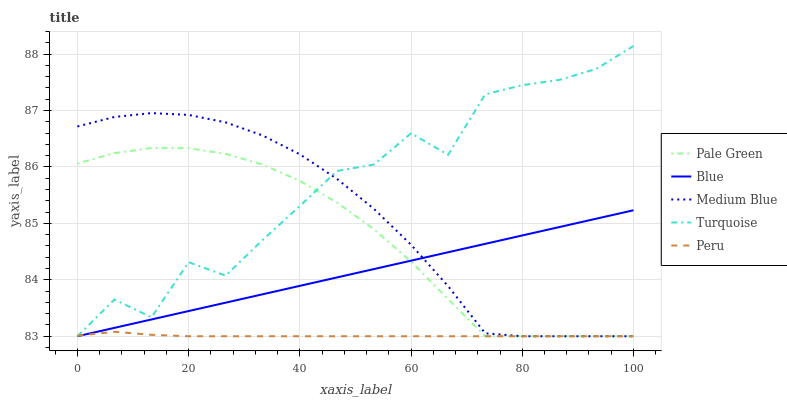Does Peru have the minimum area under the curve?
Answer yes or no. Yes. Does Turquoise have the maximum area under the curve?
Answer yes or no. Yes. Does Pale Green have the minimum area under the curve?
Answer yes or no. No. Does Pale Green have the maximum area under the curve?
Answer yes or no. No. Is Blue the smoothest?
Answer yes or no. Yes. Is Turquoise the roughest?
Answer yes or no. Yes. Is Pale Green the smoothest?
Answer yes or no. No. Is Pale Green the roughest?
Answer yes or no. No. Does Blue have the lowest value?
Answer yes or no. Yes. Does Turquoise have the highest value?
Answer yes or no. Yes. Does Pale Green have the highest value?
Answer yes or no. No. Does Blue intersect Peru?
Answer yes or no. Yes. Is Blue less than Peru?
Answer yes or no. No. Is Blue greater than Peru?
Answer yes or no. No. 